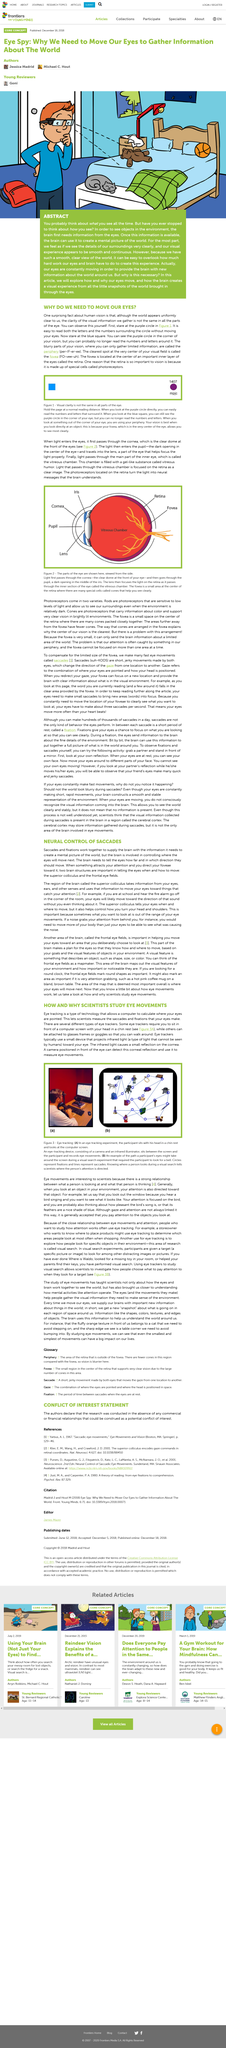Specify some key components in this picture. Photoreceptors located on the retina convert light into neural messages that the brain understands. Figure 2 displays the various components of the eye, as viewed from the side. An eye-tracking device is composed of a camera and an infrared illuminator. The fovea is the clearest spot in the visual field. Eye movements are of interest to scientists because they are directly related to a person's thoughts and what they are focusing on. 